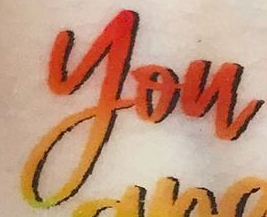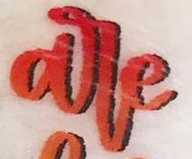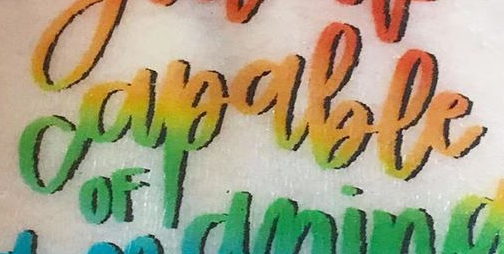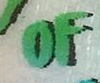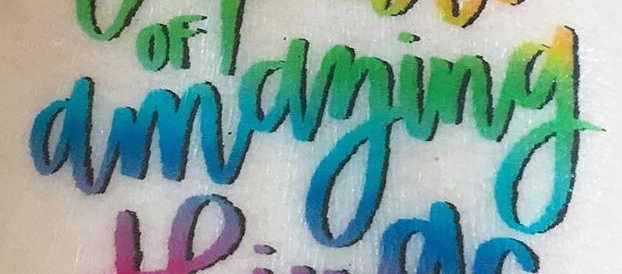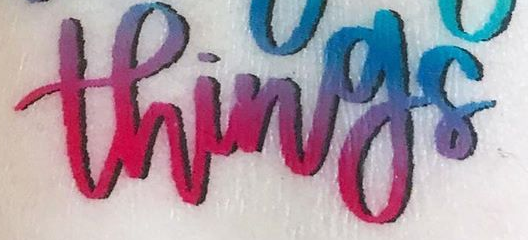Identify the words shown in these images in order, separated by a semicolon. you; are; capable; OF; amaying; things 